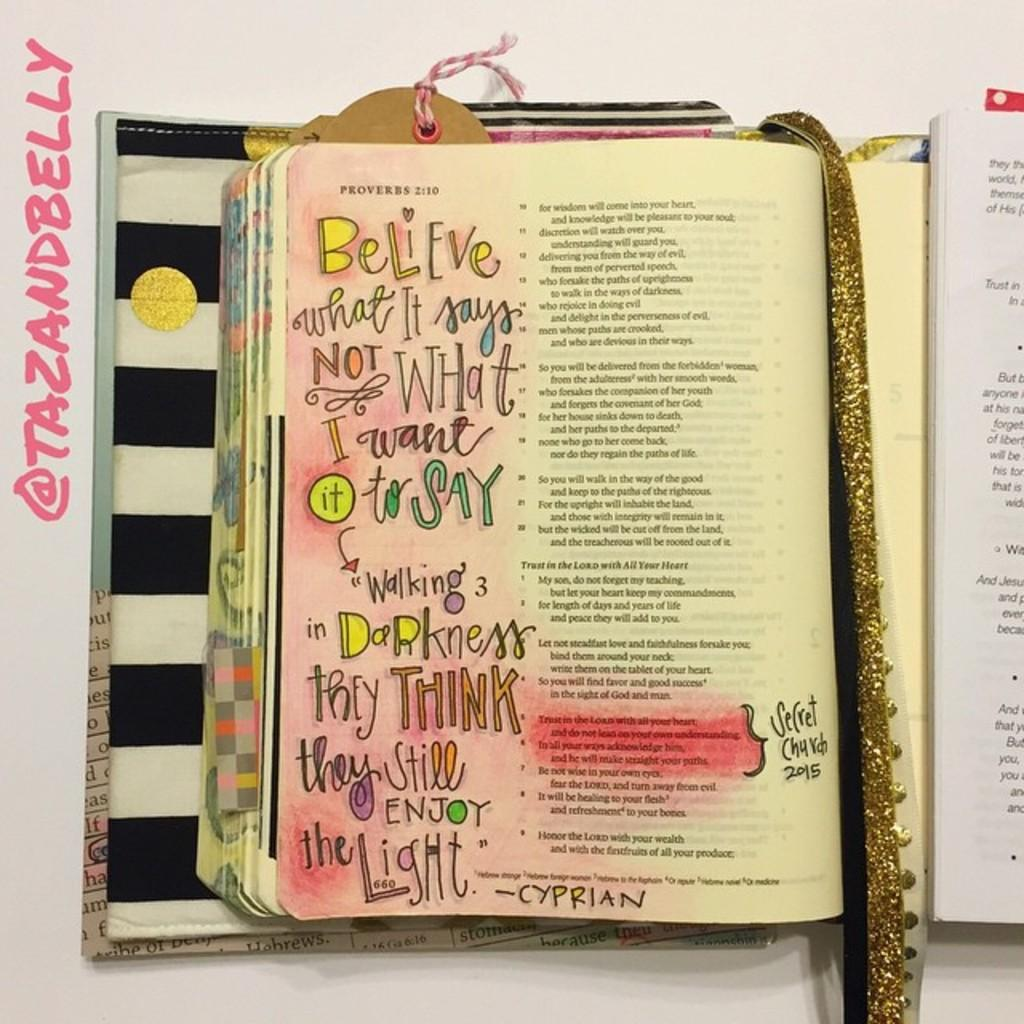<image>
Provide a brief description of the given image. A page of a bible that has been drawn on in the margins 